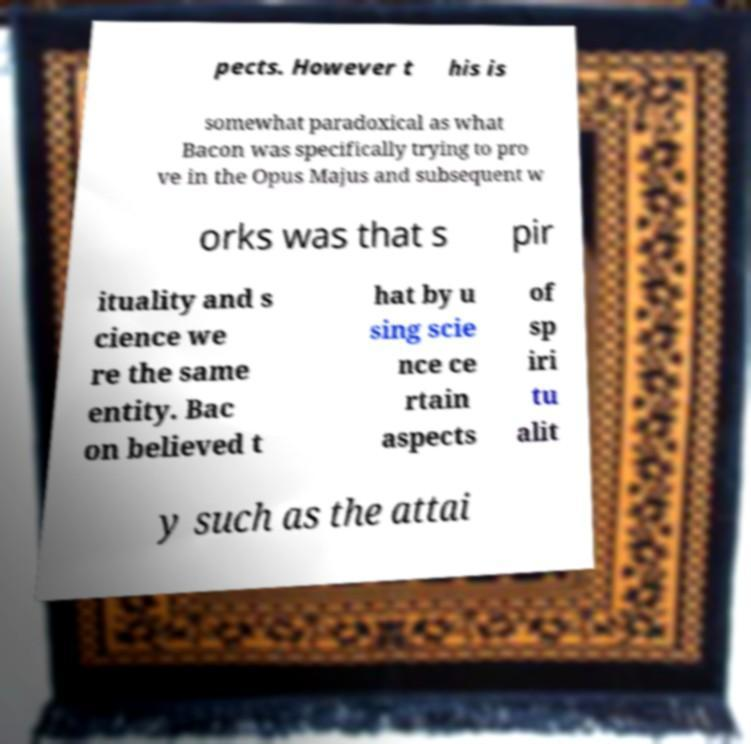There's text embedded in this image that I need extracted. Can you transcribe it verbatim? pects. However t his is somewhat paradoxical as what Bacon was specifically trying to pro ve in the Opus Majus and subsequent w orks was that s pir ituality and s cience we re the same entity. Bac on believed t hat by u sing scie nce ce rtain aspects of sp iri tu alit y such as the attai 